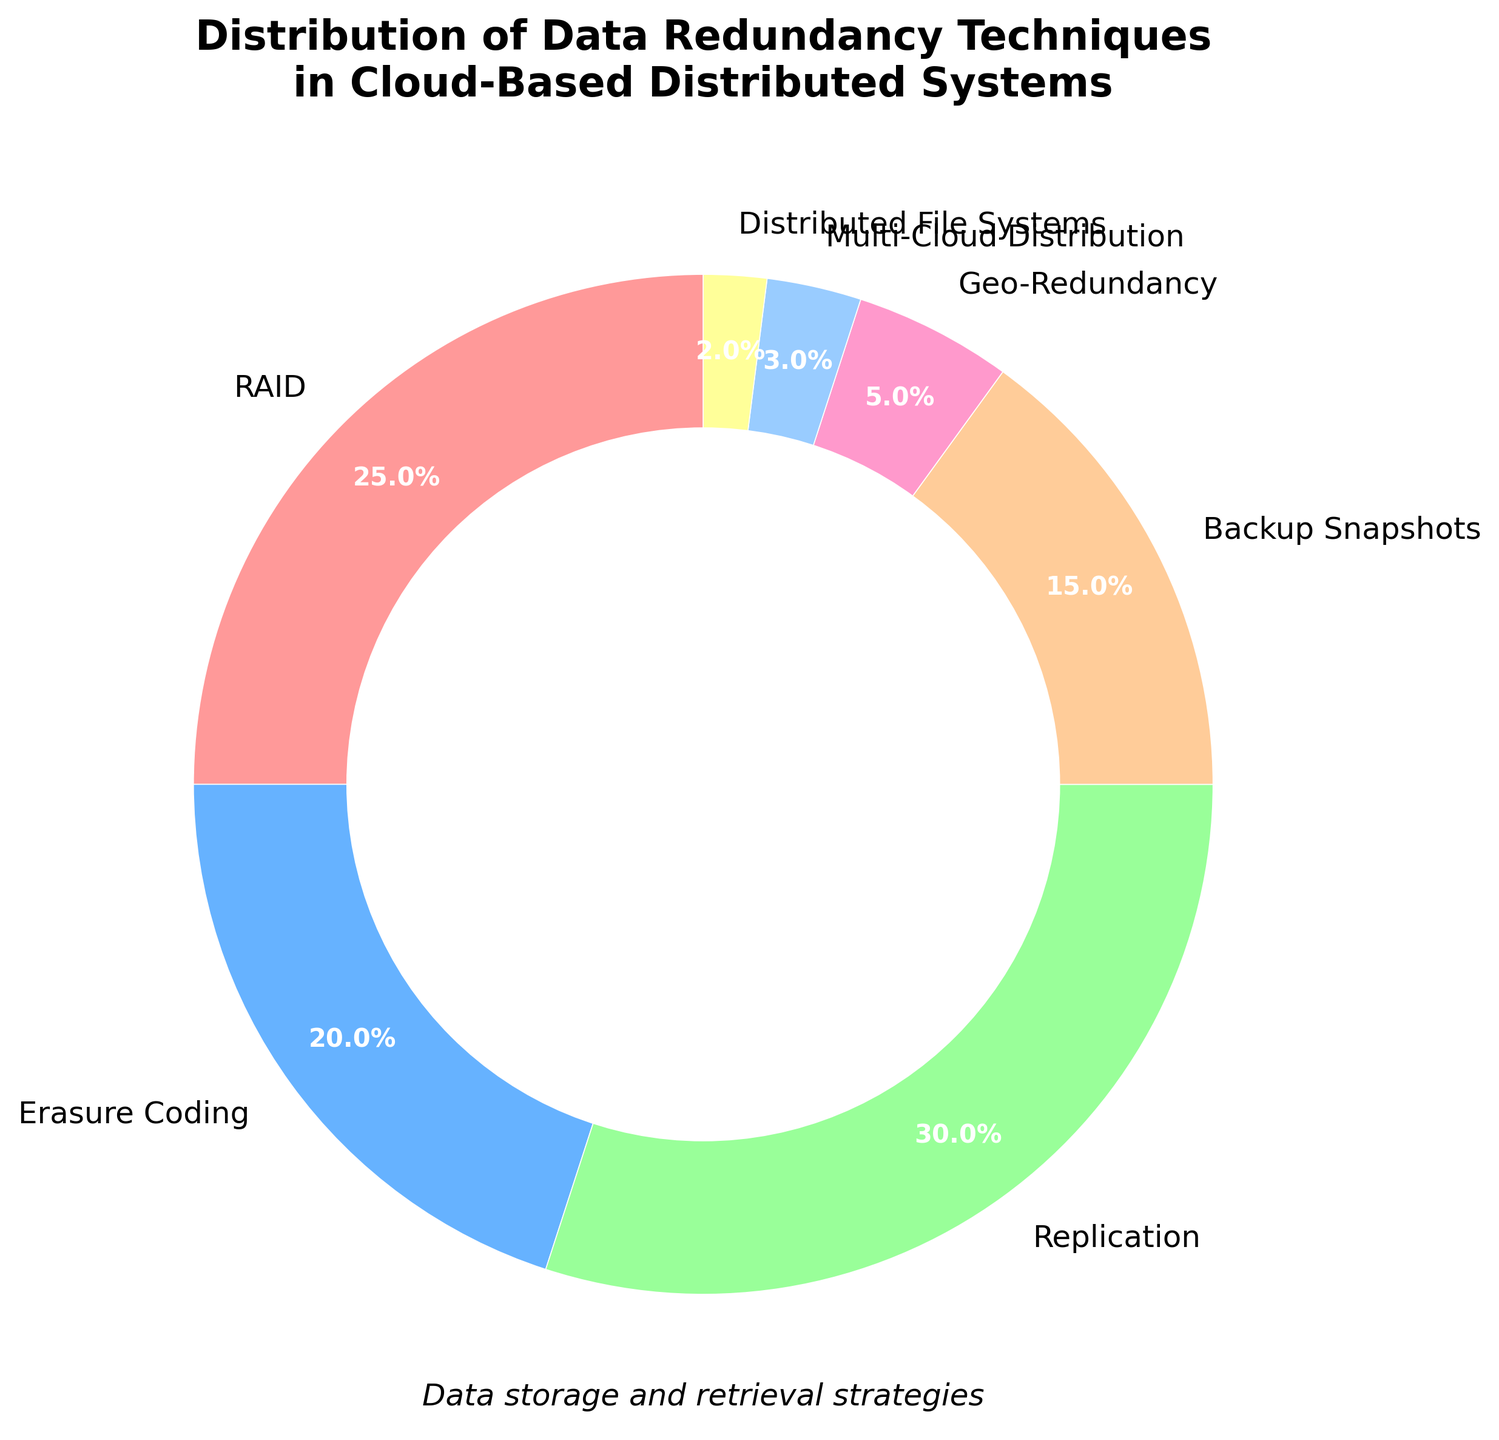What's the most commonly used data redundancy technique? The pie chart shows the percentages of different data redundancy techniques. The largest section corresponds to Replication, which occupies 30% of the chart, making it the most commonly used technique.
Answer: Replication What percentage of techniques involves Backup Snapshots and Geo-Redundancy combined? The pie chart lists Backup Snapshots at 15% and Geo-Redundancy at 5%. Adding these percentages together gives 15% + 5% = 20%.
Answer: 20% Which technique occupies the smallest portion in the pie chart? The pie chart displays multiple techniques with percentages. The smallest section corresponds to Distributed File Systems with 2%.
Answer: Distributed File Systems How much more popular is Replication compared to Multi-Cloud Distribution? Replication accounts for 30% while Multi-Cloud Distribution is at 3%. The difference is 30% - 3% = 27%, showing Replication is 27% more popular.
Answer: 27% What is the combined percentage of techniques represented by RAID and Erasure Coding? The percentages for RAID and Erasure Coding are 25% and 20%, respectively. Adding these together, 25% + 20% = 45%.
Answer: 45% Between Erasure Coding and Backup Snapshots, which has a higher percentage and by how much? Erasure Coding is 20% and Backup Snapshots is 15%. To find the difference, subtract 15% from 20%, resulting in 5%. Erasure Coding has a higher percentage by 5%.
Answer: Erasure Coding by 5% If RAID and Backup Snapshots were combined into a single category, what would be their total percentage? RAID has 25% and Backup Snapshots has 15%. Summing these gives 25% + 15% = 40%.
Answer: 40% How does the percentage of Geo-Redundancy compare to that of Erasure Coding? Geo-Redundancy is 5% while Erasure Coding is 20%. Geo-Redundancy is less popular by 20% - 5% = 15%.
Answer: Geo-Redundancy is less by 15% Which techniques together constitute nearly half of the total distribution? RAID, at 25%, and Replication, at 30%, together make 25% + 30% = 55%, which is more than half. Additionally, RAID and Erasure Coding together make up 45%.
Answer: RAID and Erasure Coding What is the visual color representation for Multi-Cloud Distribution in the chart? Observing the pie chart, Multi-Cloud Distribution is represented in the light purple color.
Answer: Light purple 